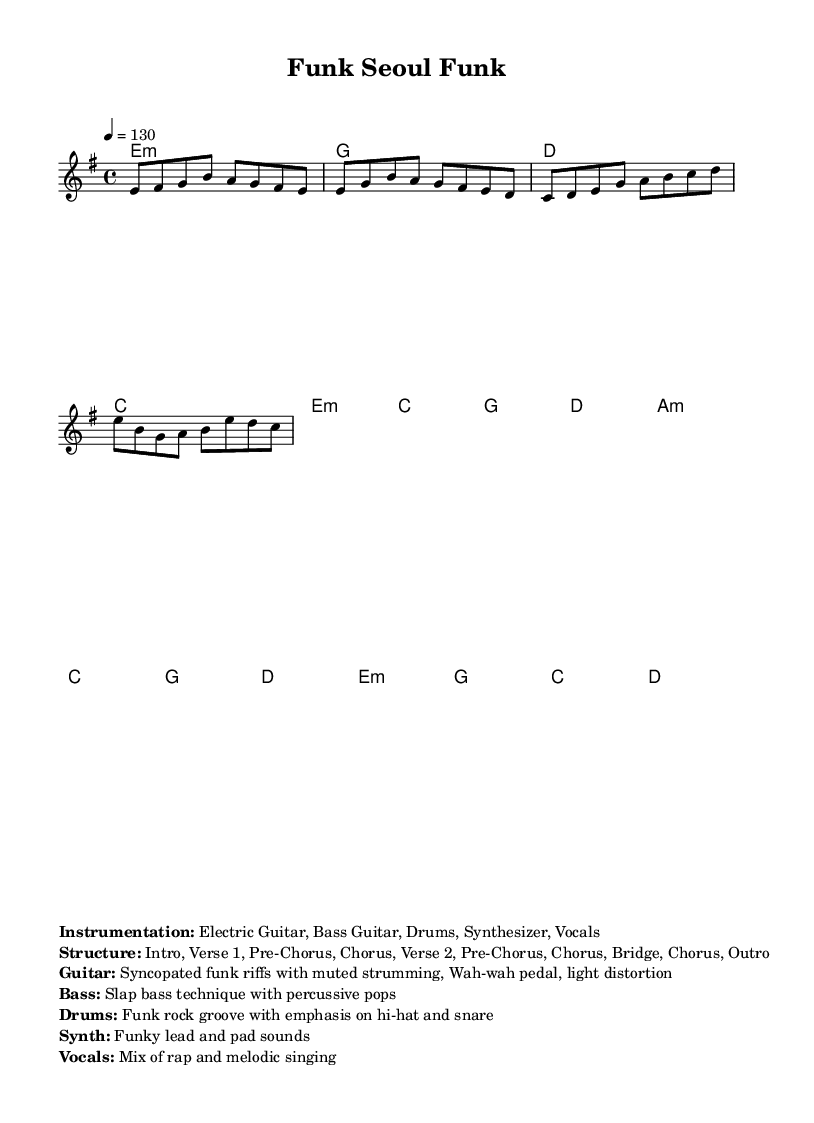What is the key signature of this music? The key signature is E minor, which has one sharp (F#). In the provided music, it is indicated at the beginning of the score.
Answer: E minor What is the time signature of this music? The time signature is 4/4, which means there are four beats in each measure, and the quarter note receives one beat. This is shown in the score right after the key signature.
Answer: 4/4 What is the tempo marking of the music? The tempo marking indicates a speed of 130 beats per minute, which is noted in the score as "4 = 130." This indicates the metronome setting for performing the piece.
Answer: 130 Identify the main instruments used in this piece. The main instruments are listed in the markup section, which specifies Electric Guitar, Bass Guitar, Drums, Synthesizer, and Vocals. This gives insight into the texture and arrangement of the music.
Answer: Electric Guitar, Bass Guitar, Drums, Synthesizer, Vocals What is the structure of this piece? The structure is outlined in the markup, detailing the various parts of the composition: Intro, Verse 1, Pre-Chorus, Chorus, Verse 2, Pre-Chorus, Chorus, Bridge, Chorus, Outro. This is essential for understanding how the music is organized.
Answer: Intro, Verse 1, Pre-Chorus, Chorus, Verse 2, Pre-Chorus, Chorus, Bridge, Chorus, Outro How does the guitar contribute to the funk rock elements in this composition? The guitar plays syncopated funk riffs with muted strumming and uses a wah-wah pedal along with light distortion. This description enhances understanding of the unique sound and style associated with funk rock.
Answer: Syncopated funk riffs with muted strumming, Wah-wah pedal, light distortion What vocal techniques are used in this piece? The vocals feature a mix of rap and melodic singing, as indicated in the instrumentation section of the score. This reflects a common characteristic in K-Pop music, which often combines various vocal styles.
Answer: Mix of rap and melodic singing 